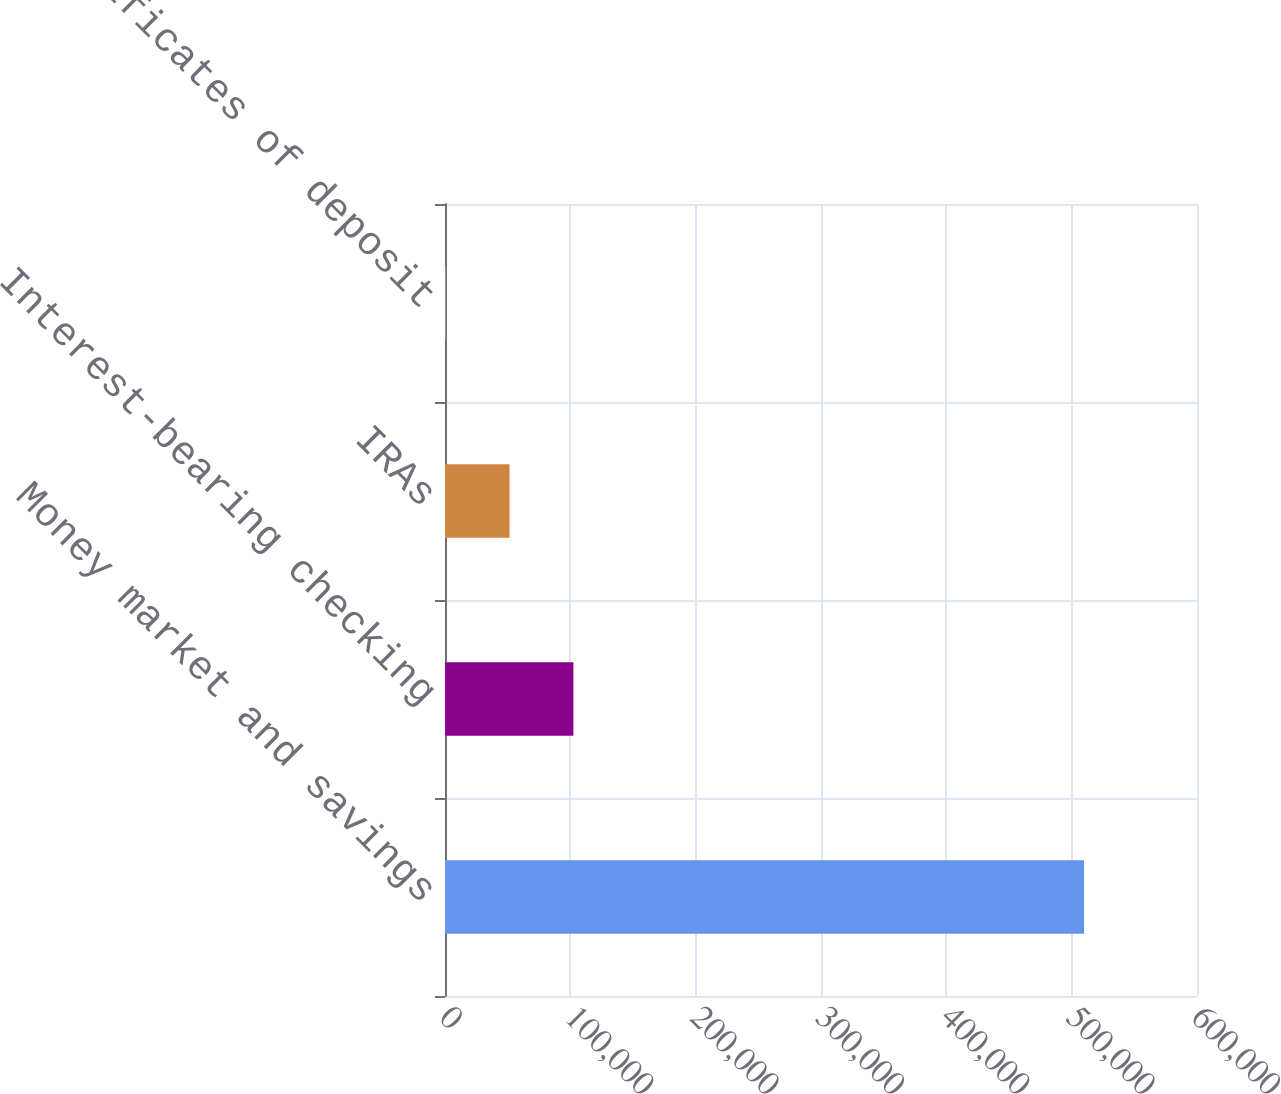Convert chart. <chart><loc_0><loc_0><loc_500><loc_500><bar_chart><fcel>Money market and savings<fcel>Interest-bearing checking<fcel>IRAs<fcel>Certificates of deposit<nl><fcel>509915<fcel>102445<fcel>51511.7<fcel>578<nl></chart> 